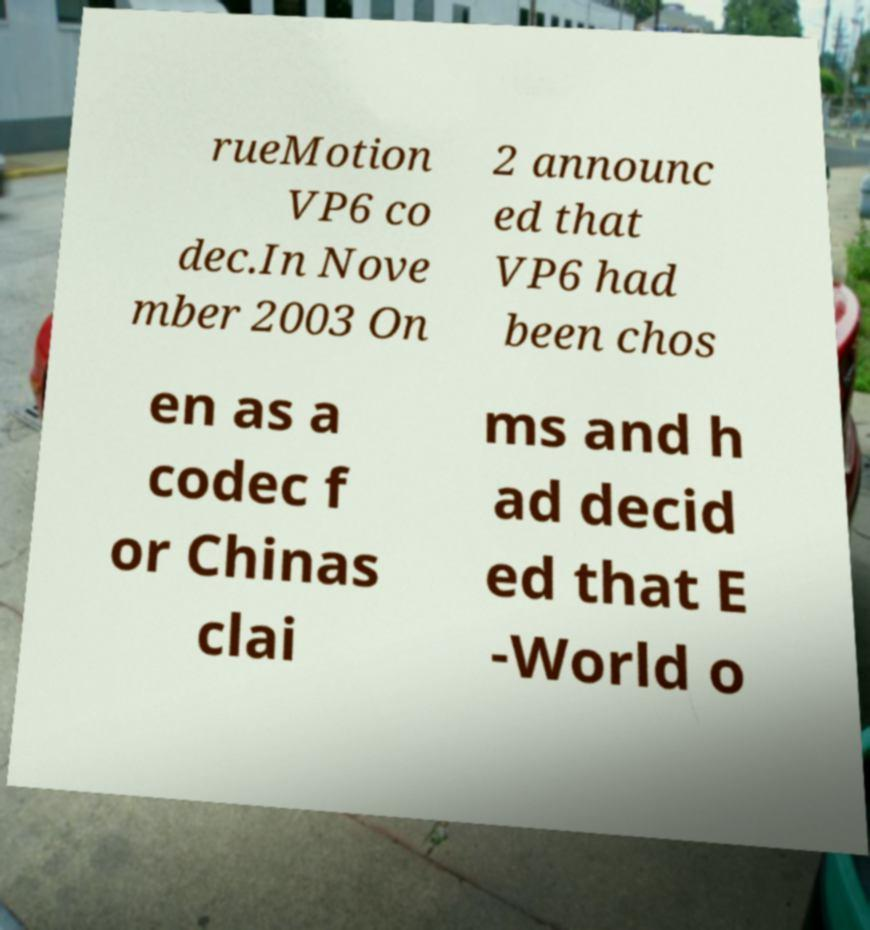There's text embedded in this image that I need extracted. Can you transcribe it verbatim? rueMotion VP6 co dec.In Nove mber 2003 On 2 announc ed that VP6 had been chos en as a codec f or Chinas clai ms and h ad decid ed that E -World o 